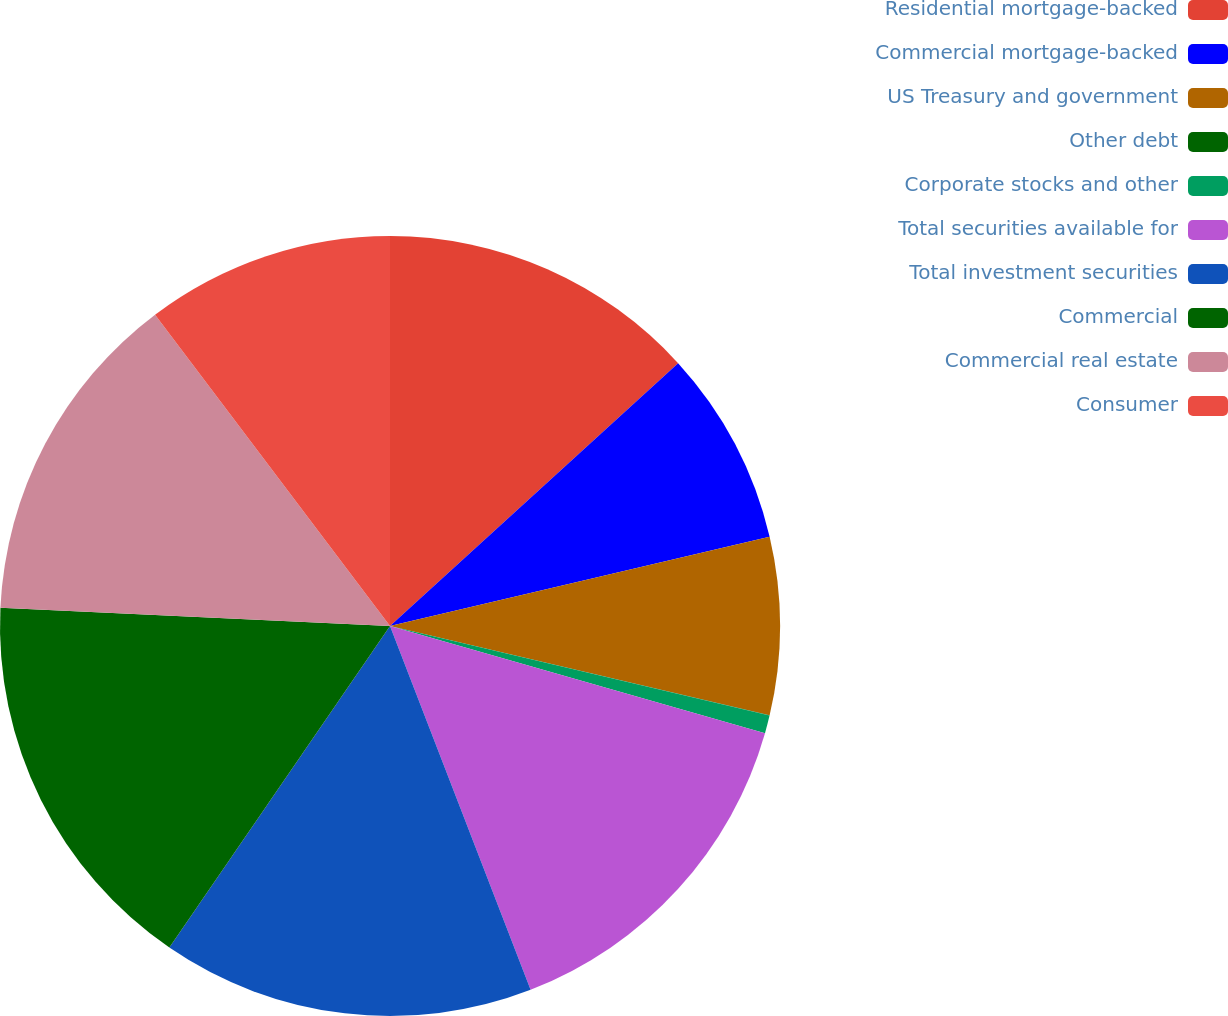<chart> <loc_0><loc_0><loc_500><loc_500><pie_chart><fcel>Residential mortgage-backed<fcel>Commercial mortgage-backed<fcel>US Treasury and government<fcel>Other debt<fcel>Corporate stocks and other<fcel>Total securities available for<fcel>Total investment securities<fcel>Commercial<fcel>Commercial real estate<fcel>Consumer<nl><fcel>13.23%<fcel>8.09%<fcel>7.36%<fcel>0.01%<fcel>0.74%<fcel>14.7%<fcel>15.44%<fcel>16.17%<fcel>13.97%<fcel>10.29%<nl></chart> 